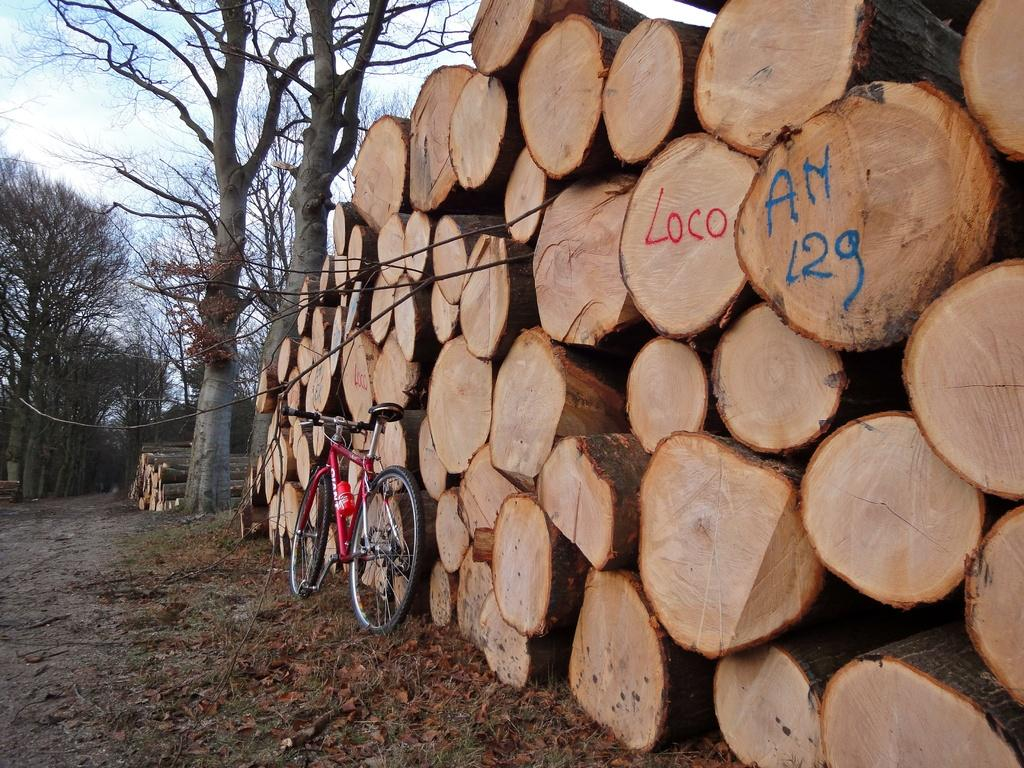What is the main object in the center of the image? There is a bicycle in the center of the image. What can be seen on the left side of the image? There are wooden logs on the left side of the image. What is visible in the background of the image? There are trees and the sky visible in the background of the image. How many pages are there in the bicycle in the image? There are no pages present in the image, as it features a bicycle and other objects. 